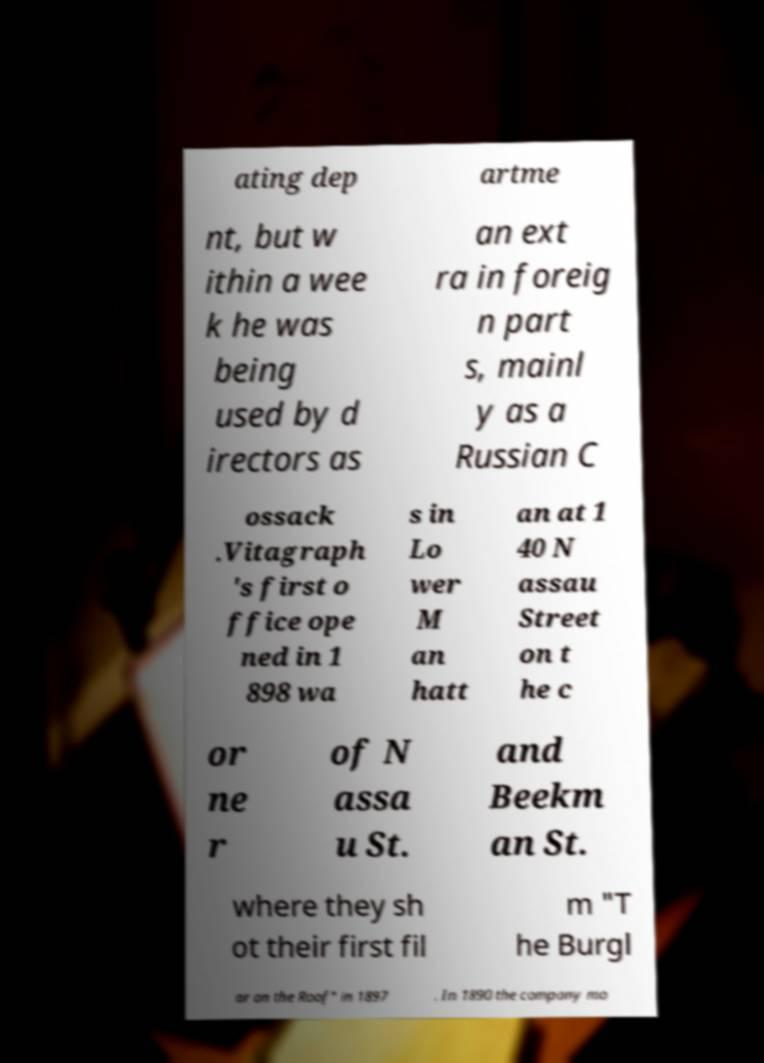Can you accurately transcribe the text from the provided image for me? ating dep artme nt, but w ithin a wee k he was being used by d irectors as an ext ra in foreig n part s, mainl y as a Russian C ossack .Vitagraph 's first o ffice ope ned in 1 898 wa s in Lo wer M an hatt an at 1 40 N assau Street on t he c or ne r of N assa u St. and Beekm an St. where they sh ot their first fil m "T he Burgl ar on the Roof" in 1897 . In 1890 the company mo 